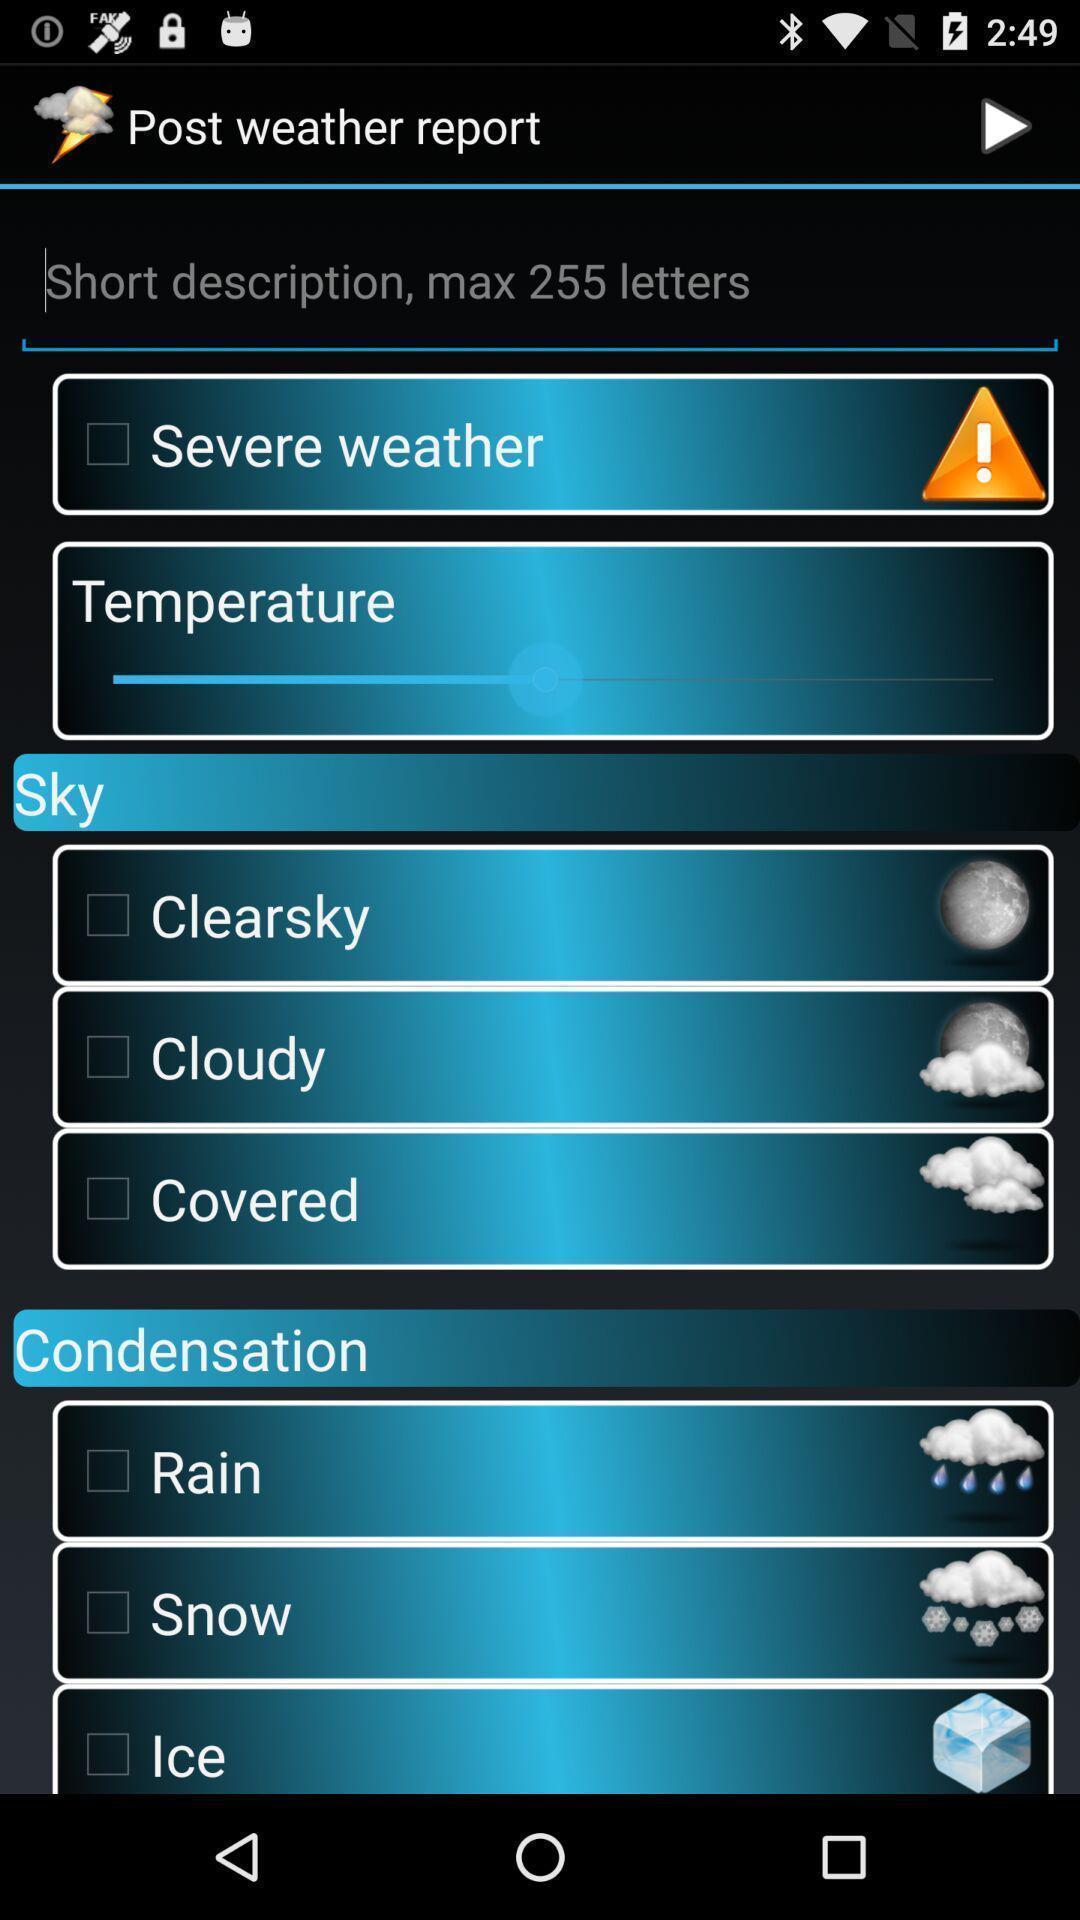Provide a textual representation of this image. Types of weather conditions list in weather report app. 